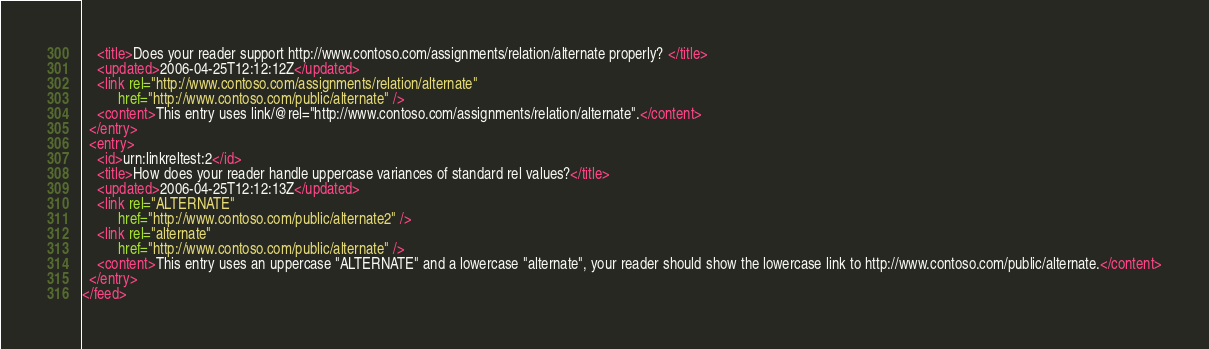Convert code to text. <code><loc_0><loc_0><loc_500><loc_500><_XML_>    <title>Does your reader support http://www.contoso.com/assignments/relation/alternate properly? </title>
    <updated>2006-04-25T12:12:12Z</updated>
    <link rel="http://www.contoso.com/assignments/relation/alternate"
          href="http://www.contoso.com/public/alternate" />
    <content>This entry uses link/@rel="http://www.contoso.com/assignments/relation/alternate".</content>
  </entry>
  <entry>
    <id>urn:linkreltest:2</id>
    <title>How does your reader handle uppercase variances of standard rel values?</title>
    <updated>2006-04-25T12:12:13Z</updated>
    <link rel="ALTERNATE"
          href="http://www.contoso.com/public/alternate2" />
    <link rel="alternate"
          href="http://www.contoso.com/public/alternate" />
    <content>This entry uses an uppercase "ALTERNATE" and a lowercase "alternate", your reader should show the lowercase link to http://www.contoso.com/public/alternate.</content>
  </entry>
</feed>
</code> 